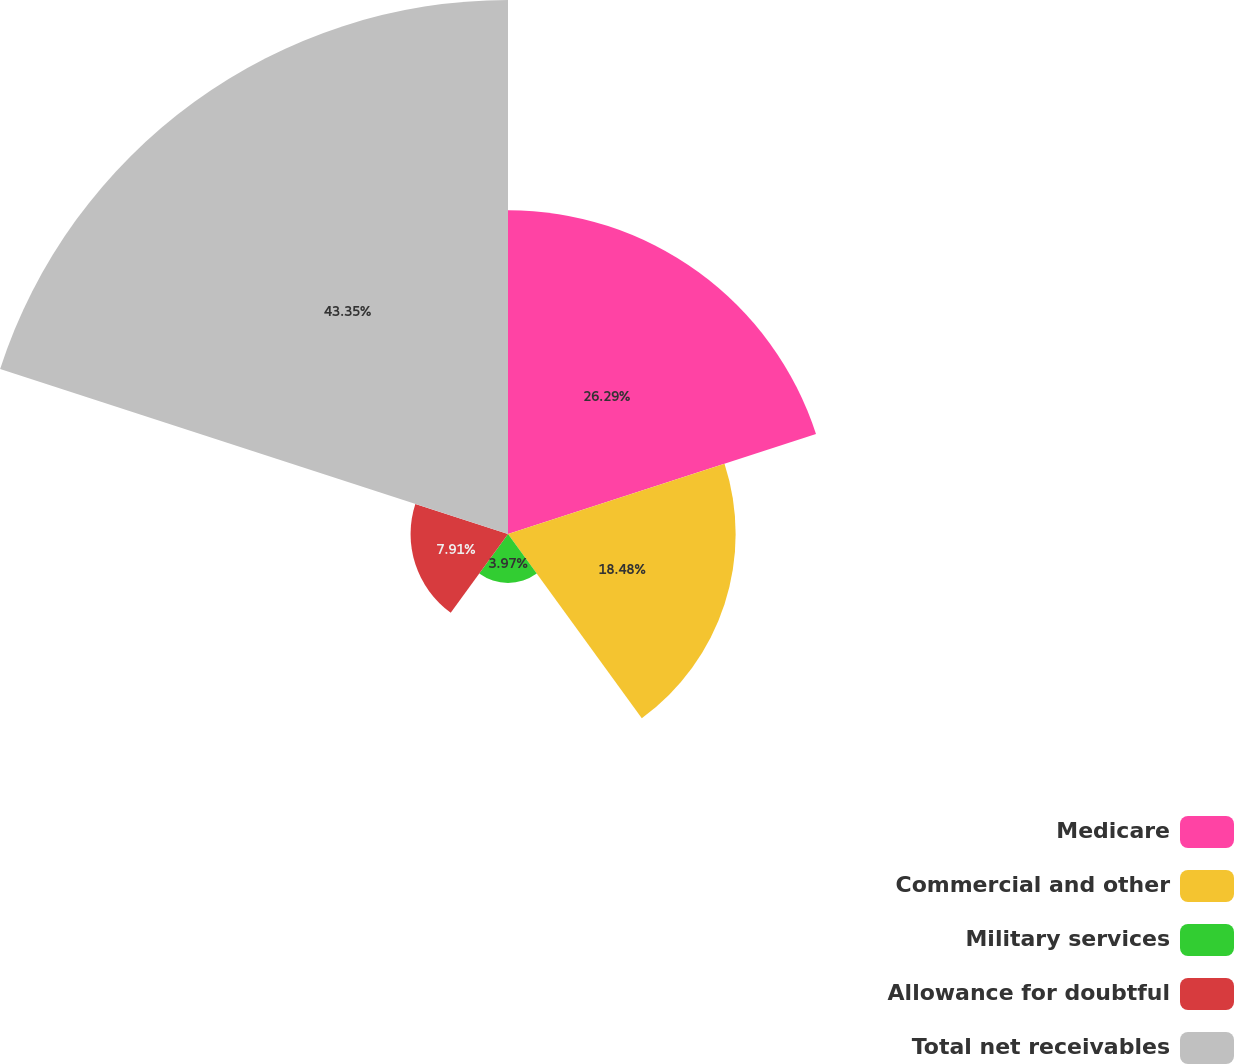Convert chart. <chart><loc_0><loc_0><loc_500><loc_500><pie_chart><fcel>Medicare<fcel>Commercial and other<fcel>Military services<fcel>Allowance for doubtful<fcel>Total net receivables<nl><fcel>26.29%<fcel>18.48%<fcel>3.97%<fcel>7.91%<fcel>43.35%<nl></chart> 